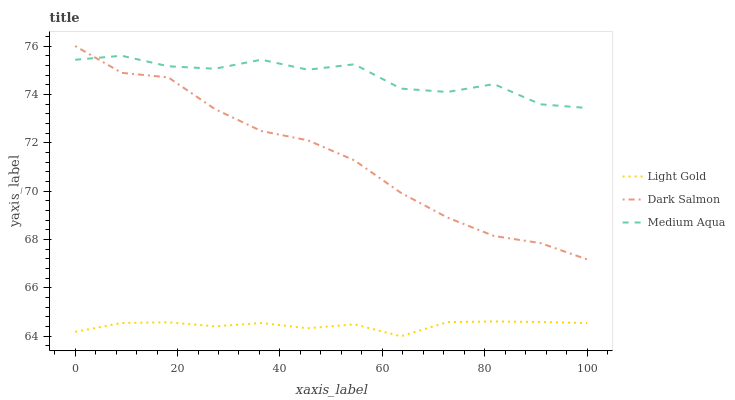Does Light Gold have the minimum area under the curve?
Answer yes or no. Yes. Does Medium Aqua have the maximum area under the curve?
Answer yes or no. Yes. Does Dark Salmon have the minimum area under the curve?
Answer yes or no. No. Does Dark Salmon have the maximum area under the curve?
Answer yes or no. No. Is Light Gold the smoothest?
Answer yes or no. Yes. Is Medium Aqua the roughest?
Answer yes or no. Yes. Is Dark Salmon the smoothest?
Answer yes or no. No. Is Dark Salmon the roughest?
Answer yes or no. No. Does Light Gold have the lowest value?
Answer yes or no. Yes. Does Dark Salmon have the lowest value?
Answer yes or no. No. Does Dark Salmon have the highest value?
Answer yes or no. Yes. Does Light Gold have the highest value?
Answer yes or no. No. Is Light Gold less than Dark Salmon?
Answer yes or no. Yes. Is Medium Aqua greater than Light Gold?
Answer yes or no. Yes. Does Medium Aqua intersect Dark Salmon?
Answer yes or no. Yes. Is Medium Aqua less than Dark Salmon?
Answer yes or no. No. Is Medium Aqua greater than Dark Salmon?
Answer yes or no. No. Does Light Gold intersect Dark Salmon?
Answer yes or no. No. 